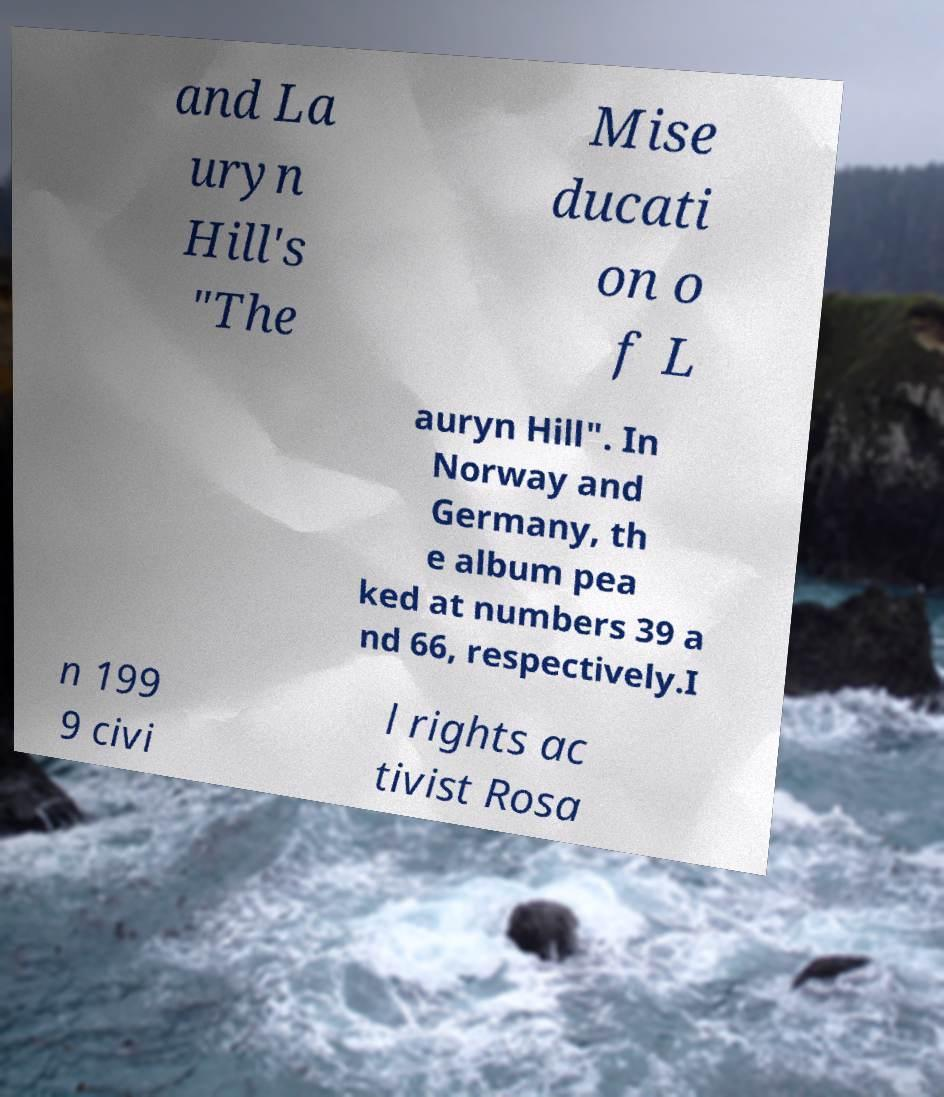There's text embedded in this image that I need extracted. Can you transcribe it verbatim? and La uryn Hill's "The Mise ducati on o f L auryn Hill". In Norway and Germany, th e album pea ked at numbers 39 a nd 66, respectively.I n 199 9 civi l rights ac tivist Rosa 